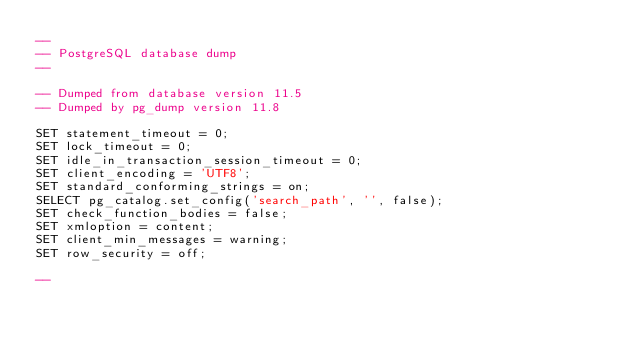<code> <loc_0><loc_0><loc_500><loc_500><_SQL_>--
-- PostgreSQL database dump
--

-- Dumped from database version 11.5
-- Dumped by pg_dump version 11.8

SET statement_timeout = 0;
SET lock_timeout = 0;
SET idle_in_transaction_session_timeout = 0;
SET client_encoding = 'UTF8';
SET standard_conforming_strings = on;
SELECT pg_catalog.set_config('search_path', '', false);
SET check_function_bodies = false;
SET xmloption = content;
SET client_min_messages = warning;
SET row_security = off;

--</code> 